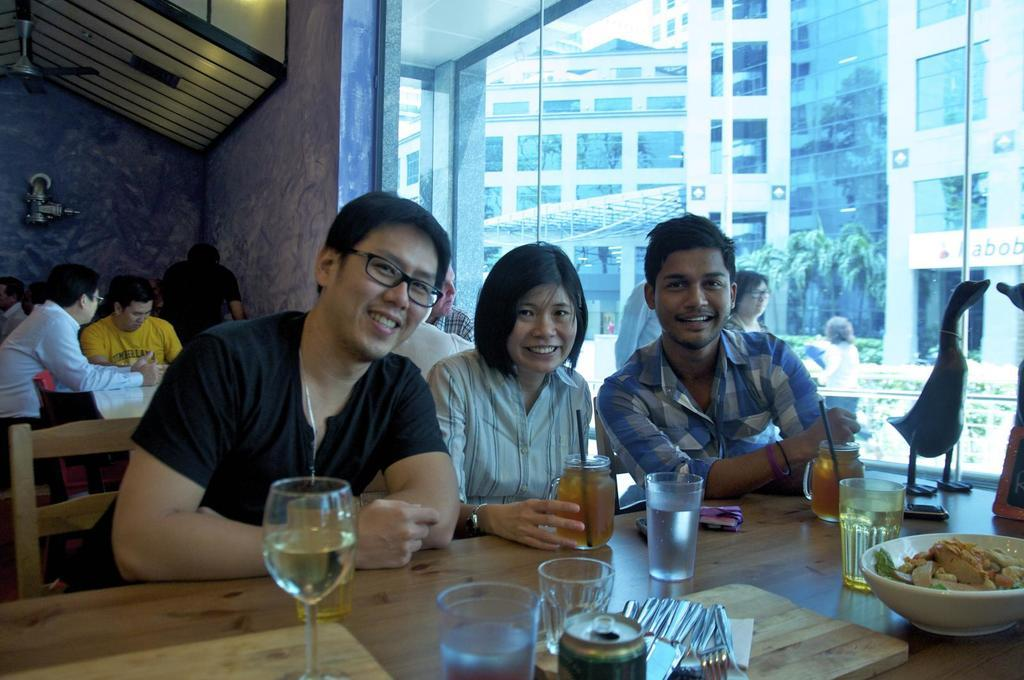What are the people in the image doing? The people in the image are sitting on chairs. What is present on the table in the image? There is a wine glass, a juice can, and a bowl with food items on the table. What might the people be using to drink in the image? The wine glass on the table might be used for drinking. How many rabbits are present in the image? There are no rabbits present in the image. What type of care is being provided to the apple in the image? There is no apple present in the image, and therefore no care is being provided. 